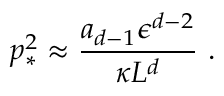<formula> <loc_0><loc_0><loc_500><loc_500>p _ { * } ^ { 2 } \approx { \frac { a _ { d - 1 } \epsilon ^ { d - 2 } } { \kappa L ^ { d } } } .</formula> 